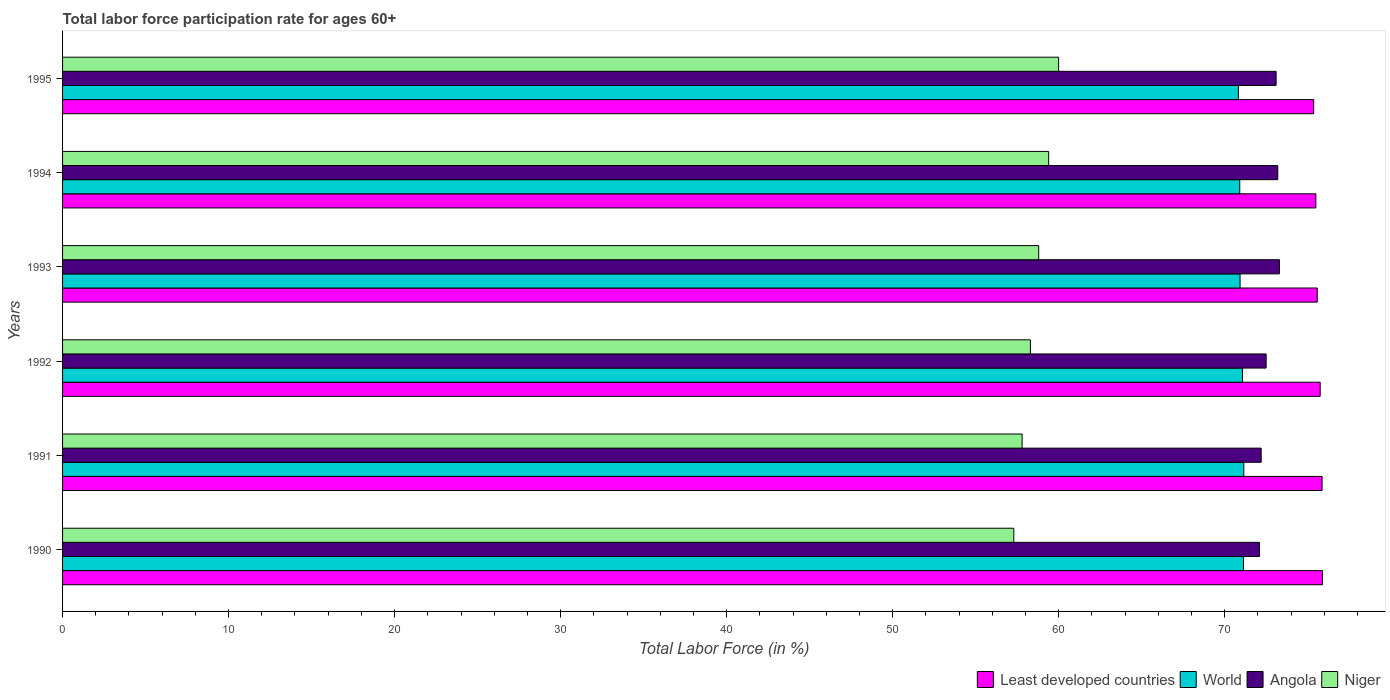How many different coloured bars are there?
Your answer should be compact. 4. How many groups of bars are there?
Ensure brevity in your answer.  6. Are the number of bars on each tick of the Y-axis equal?
Ensure brevity in your answer.  Yes. How many bars are there on the 3rd tick from the bottom?
Offer a terse response. 4. What is the label of the 2nd group of bars from the top?
Make the answer very short. 1994. In how many cases, is the number of bars for a given year not equal to the number of legend labels?
Provide a short and direct response. 0. What is the labor force participation rate in Niger in 1991?
Offer a terse response. 57.8. Across all years, what is the minimum labor force participation rate in Niger?
Provide a succinct answer. 57.3. In which year was the labor force participation rate in Angola maximum?
Provide a succinct answer. 1993. In which year was the labor force participation rate in Least developed countries minimum?
Provide a short and direct response. 1995. What is the total labor force participation rate in Angola in the graph?
Ensure brevity in your answer.  436.4. What is the difference between the labor force participation rate in Angola in 1990 and that in 1992?
Provide a short and direct response. -0.4. What is the difference between the labor force participation rate in World in 1992 and the labor force participation rate in Niger in 1991?
Your answer should be very brief. 13.28. What is the average labor force participation rate in Angola per year?
Keep it short and to the point. 72.73. In the year 1993, what is the difference between the labor force participation rate in Least developed countries and labor force participation rate in Niger?
Provide a short and direct response. 16.78. In how many years, is the labor force participation rate in Angola greater than 22 %?
Provide a short and direct response. 6. What is the ratio of the labor force participation rate in World in 1990 to that in 1991?
Ensure brevity in your answer.  1. Is the labor force participation rate in Niger in 1992 less than that in 1993?
Give a very brief answer. Yes. What is the difference between the highest and the second highest labor force participation rate in World?
Ensure brevity in your answer.  0.02. What is the difference between the highest and the lowest labor force participation rate in Niger?
Give a very brief answer. 2.7. In how many years, is the labor force participation rate in World greater than the average labor force participation rate in World taken over all years?
Your response must be concise. 3. What does the 4th bar from the top in 1992 represents?
Ensure brevity in your answer.  Least developed countries. What does the 3rd bar from the bottom in 1992 represents?
Make the answer very short. Angola. Is it the case that in every year, the sum of the labor force participation rate in Angola and labor force participation rate in Niger is greater than the labor force participation rate in World?
Offer a very short reply. Yes. How many bars are there?
Your answer should be compact. 24. Are all the bars in the graph horizontal?
Make the answer very short. Yes. How many years are there in the graph?
Keep it short and to the point. 6. What is the difference between two consecutive major ticks on the X-axis?
Provide a succinct answer. 10. Where does the legend appear in the graph?
Provide a succinct answer. Bottom right. What is the title of the graph?
Your answer should be very brief. Total labor force participation rate for ages 60+. Does "Puerto Rico" appear as one of the legend labels in the graph?
Your answer should be compact. No. What is the label or title of the X-axis?
Keep it short and to the point. Total Labor Force (in %). What is the Total Labor Force (in %) of Least developed countries in 1990?
Provide a succinct answer. 75.89. What is the Total Labor Force (in %) of World in 1990?
Your answer should be compact. 71.13. What is the Total Labor Force (in %) of Angola in 1990?
Provide a succinct answer. 72.1. What is the Total Labor Force (in %) in Niger in 1990?
Your response must be concise. 57.3. What is the Total Labor Force (in %) in Least developed countries in 1991?
Make the answer very short. 75.87. What is the Total Labor Force (in %) of World in 1991?
Provide a succinct answer. 71.15. What is the Total Labor Force (in %) of Angola in 1991?
Offer a terse response. 72.2. What is the Total Labor Force (in %) of Niger in 1991?
Provide a short and direct response. 57.8. What is the Total Labor Force (in %) in Least developed countries in 1992?
Your response must be concise. 75.75. What is the Total Labor Force (in %) of World in 1992?
Your answer should be compact. 71.08. What is the Total Labor Force (in %) of Angola in 1992?
Give a very brief answer. 72.5. What is the Total Labor Force (in %) of Niger in 1992?
Keep it short and to the point. 58.3. What is the Total Labor Force (in %) in Least developed countries in 1993?
Provide a succinct answer. 75.58. What is the Total Labor Force (in %) in World in 1993?
Your answer should be very brief. 70.93. What is the Total Labor Force (in %) of Angola in 1993?
Offer a terse response. 73.3. What is the Total Labor Force (in %) of Niger in 1993?
Make the answer very short. 58.8. What is the Total Labor Force (in %) of Least developed countries in 1994?
Your answer should be very brief. 75.49. What is the Total Labor Force (in %) in World in 1994?
Offer a terse response. 70.91. What is the Total Labor Force (in %) in Angola in 1994?
Offer a very short reply. 73.2. What is the Total Labor Force (in %) of Niger in 1994?
Your response must be concise. 59.4. What is the Total Labor Force (in %) in Least developed countries in 1995?
Your response must be concise. 75.36. What is the Total Labor Force (in %) in World in 1995?
Offer a terse response. 70.83. What is the Total Labor Force (in %) in Angola in 1995?
Offer a terse response. 73.1. What is the Total Labor Force (in %) in Niger in 1995?
Make the answer very short. 60. Across all years, what is the maximum Total Labor Force (in %) of Least developed countries?
Make the answer very short. 75.89. Across all years, what is the maximum Total Labor Force (in %) in World?
Make the answer very short. 71.15. Across all years, what is the maximum Total Labor Force (in %) of Angola?
Provide a succinct answer. 73.3. Across all years, what is the maximum Total Labor Force (in %) of Niger?
Offer a very short reply. 60. Across all years, what is the minimum Total Labor Force (in %) in Least developed countries?
Make the answer very short. 75.36. Across all years, what is the minimum Total Labor Force (in %) of World?
Offer a terse response. 70.83. Across all years, what is the minimum Total Labor Force (in %) in Angola?
Offer a very short reply. 72.1. Across all years, what is the minimum Total Labor Force (in %) of Niger?
Make the answer very short. 57.3. What is the total Total Labor Force (in %) of Least developed countries in the graph?
Offer a terse response. 453.95. What is the total Total Labor Force (in %) in World in the graph?
Ensure brevity in your answer.  426.03. What is the total Total Labor Force (in %) in Angola in the graph?
Make the answer very short. 436.4. What is the total Total Labor Force (in %) of Niger in the graph?
Ensure brevity in your answer.  351.6. What is the difference between the Total Labor Force (in %) in Least developed countries in 1990 and that in 1991?
Your answer should be compact. 0.03. What is the difference between the Total Labor Force (in %) in World in 1990 and that in 1991?
Make the answer very short. -0.02. What is the difference between the Total Labor Force (in %) in Niger in 1990 and that in 1991?
Offer a very short reply. -0.5. What is the difference between the Total Labor Force (in %) in Least developed countries in 1990 and that in 1992?
Make the answer very short. 0.14. What is the difference between the Total Labor Force (in %) of World in 1990 and that in 1992?
Make the answer very short. 0.06. What is the difference between the Total Labor Force (in %) in Angola in 1990 and that in 1992?
Provide a succinct answer. -0.4. What is the difference between the Total Labor Force (in %) in Least developed countries in 1990 and that in 1993?
Provide a short and direct response. 0.32. What is the difference between the Total Labor Force (in %) of World in 1990 and that in 1993?
Provide a short and direct response. 0.2. What is the difference between the Total Labor Force (in %) in Angola in 1990 and that in 1993?
Your response must be concise. -1.2. What is the difference between the Total Labor Force (in %) in World in 1990 and that in 1994?
Provide a succinct answer. 0.22. What is the difference between the Total Labor Force (in %) in Angola in 1990 and that in 1994?
Offer a very short reply. -1.1. What is the difference between the Total Labor Force (in %) of Least developed countries in 1990 and that in 1995?
Provide a short and direct response. 0.53. What is the difference between the Total Labor Force (in %) of World in 1990 and that in 1995?
Your answer should be very brief. 0.3. What is the difference between the Total Labor Force (in %) of Angola in 1990 and that in 1995?
Make the answer very short. -1. What is the difference between the Total Labor Force (in %) in Least developed countries in 1991 and that in 1992?
Offer a terse response. 0.11. What is the difference between the Total Labor Force (in %) of World in 1991 and that in 1992?
Your answer should be compact. 0.08. What is the difference between the Total Labor Force (in %) in Angola in 1991 and that in 1992?
Offer a very short reply. -0.3. What is the difference between the Total Labor Force (in %) of Least developed countries in 1991 and that in 1993?
Your answer should be very brief. 0.29. What is the difference between the Total Labor Force (in %) in World in 1991 and that in 1993?
Give a very brief answer. 0.22. What is the difference between the Total Labor Force (in %) of Angola in 1991 and that in 1993?
Provide a succinct answer. -1.1. What is the difference between the Total Labor Force (in %) in Least developed countries in 1991 and that in 1994?
Give a very brief answer. 0.37. What is the difference between the Total Labor Force (in %) of World in 1991 and that in 1994?
Your answer should be compact. 0.24. What is the difference between the Total Labor Force (in %) in Least developed countries in 1991 and that in 1995?
Keep it short and to the point. 0.51. What is the difference between the Total Labor Force (in %) in World in 1991 and that in 1995?
Give a very brief answer. 0.32. What is the difference between the Total Labor Force (in %) of Angola in 1991 and that in 1995?
Your answer should be compact. -0.9. What is the difference between the Total Labor Force (in %) in Niger in 1991 and that in 1995?
Offer a terse response. -2.2. What is the difference between the Total Labor Force (in %) of Least developed countries in 1992 and that in 1993?
Provide a short and direct response. 0.18. What is the difference between the Total Labor Force (in %) of World in 1992 and that in 1993?
Your response must be concise. 0.15. What is the difference between the Total Labor Force (in %) in Least developed countries in 1992 and that in 1994?
Offer a very short reply. 0.26. What is the difference between the Total Labor Force (in %) of World in 1992 and that in 1994?
Make the answer very short. 0.17. What is the difference between the Total Labor Force (in %) of Least developed countries in 1992 and that in 1995?
Provide a succinct answer. 0.39. What is the difference between the Total Labor Force (in %) in World in 1992 and that in 1995?
Provide a short and direct response. 0.25. What is the difference between the Total Labor Force (in %) in Least developed countries in 1993 and that in 1994?
Offer a terse response. 0.08. What is the difference between the Total Labor Force (in %) of World in 1993 and that in 1994?
Make the answer very short. 0.02. What is the difference between the Total Labor Force (in %) of Angola in 1993 and that in 1994?
Offer a terse response. 0.1. What is the difference between the Total Labor Force (in %) in Least developed countries in 1993 and that in 1995?
Provide a short and direct response. 0.22. What is the difference between the Total Labor Force (in %) in Niger in 1993 and that in 1995?
Give a very brief answer. -1.2. What is the difference between the Total Labor Force (in %) of Least developed countries in 1994 and that in 1995?
Your answer should be compact. 0.13. What is the difference between the Total Labor Force (in %) in World in 1994 and that in 1995?
Provide a succinct answer. 0.08. What is the difference between the Total Labor Force (in %) of Niger in 1994 and that in 1995?
Your answer should be very brief. -0.6. What is the difference between the Total Labor Force (in %) of Least developed countries in 1990 and the Total Labor Force (in %) of World in 1991?
Keep it short and to the point. 4.74. What is the difference between the Total Labor Force (in %) in Least developed countries in 1990 and the Total Labor Force (in %) in Angola in 1991?
Give a very brief answer. 3.69. What is the difference between the Total Labor Force (in %) in Least developed countries in 1990 and the Total Labor Force (in %) in Niger in 1991?
Ensure brevity in your answer.  18.09. What is the difference between the Total Labor Force (in %) of World in 1990 and the Total Labor Force (in %) of Angola in 1991?
Offer a terse response. -1.07. What is the difference between the Total Labor Force (in %) of World in 1990 and the Total Labor Force (in %) of Niger in 1991?
Your answer should be very brief. 13.33. What is the difference between the Total Labor Force (in %) in Least developed countries in 1990 and the Total Labor Force (in %) in World in 1992?
Offer a very short reply. 4.82. What is the difference between the Total Labor Force (in %) of Least developed countries in 1990 and the Total Labor Force (in %) of Angola in 1992?
Offer a terse response. 3.39. What is the difference between the Total Labor Force (in %) of Least developed countries in 1990 and the Total Labor Force (in %) of Niger in 1992?
Ensure brevity in your answer.  17.59. What is the difference between the Total Labor Force (in %) of World in 1990 and the Total Labor Force (in %) of Angola in 1992?
Give a very brief answer. -1.37. What is the difference between the Total Labor Force (in %) in World in 1990 and the Total Labor Force (in %) in Niger in 1992?
Your response must be concise. 12.83. What is the difference between the Total Labor Force (in %) in Angola in 1990 and the Total Labor Force (in %) in Niger in 1992?
Your answer should be compact. 13.8. What is the difference between the Total Labor Force (in %) of Least developed countries in 1990 and the Total Labor Force (in %) of World in 1993?
Your answer should be compact. 4.97. What is the difference between the Total Labor Force (in %) in Least developed countries in 1990 and the Total Labor Force (in %) in Angola in 1993?
Ensure brevity in your answer.  2.59. What is the difference between the Total Labor Force (in %) in Least developed countries in 1990 and the Total Labor Force (in %) in Niger in 1993?
Your answer should be compact. 17.09. What is the difference between the Total Labor Force (in %) in World in 1990 and the Total Labor Force (in %) in Angola in 1993?
Give a very brief answer. -2.17. What is the difference between the Total Labor Force (in %) in World in 1990 and the Total Labor Force (in %) in Niger in 1993?
Ensure brevity in your answer.  12.33. What is the difference between the Total Labor Force (in %) in Least developed countries in 1990 and the Total Labor Force (in %) in World in 1994?
Offer a terse response. 4.98. What is the difference between the Total Labor Force (in %) of Least developed countries in 1990 and the Total Labor Force (in %) of Angola in 1994?
Your response must be concise. 2.69. What is the difference between the Total Labor Force (in %) in Least developed countries in 1990 and the Total Labor Force (in %) in Niger in 1994?
Make the answer very short. 16.49. What is the difference between the Total Labor Force (in %) of World in 1990 and the Total Labor Force (in %) of Angola in 1994?
Your answer should be very brief. -2.07. What is the difference between the Total Labor Force (in %) of World in 1990 and the Total Labor Force (in %) of Niger in 1994?
Provide a succinct answer. 11.73. What is the difference between the Total Labor Force (in %) in Least developed countries in 1990 and the Total Labor Force (in %) in World in 1995?
Your answer should be compact. 5.07. What is the difference between the Total Labor Force (in %) of Least developed countries in 1990 and the Total Labor Force (in %) of Angola in 1995?
Give a very brief answer. 2.79. What is the difference between the Total Labor Force (in %) in Least developed countries in 1990 and the Total Labor Force (in %) in Niger in 1995?
Give a very brief answer. 15.89. What is the difference between the Total Labor Force (in %) of World in 1990 and the Total Labor Force (in %) of Angola in 1995?
Provide a succinct answer. -1.97. What is the difference between the Total Labor Force (in %) of World in 1990 and the Total Labor Force (in %) of Niger in 1995?
Provide a short and direct response. 11.13. What is the difference between the Total Labor Force (in %) of Least developed countries in 1991 and the Total Labor Force (in %) of World in 1992?
Keep it short and to the point. 4.79. What is the difference between the Total Labor Force (in %) in Least developed countries in 1991 and the Total Labor Force (in %) in Angola in 1992?
Offer a very short reply. 3.37. What is the difference between the Total Labor Force (in %) of Least developed countries in 1991 and the Total Labor Force (in %) of Niger in 1992?
Give a very brief answer. 17.57. What is the difference between the Total Labor Force (in %) of World in 1991 and the Total Labor Force (in %) of Angola in 1992?
Give a very brief answer. -1.35. What is the difference between the Total Labor Force (in %) in World in 1991 and the Total Labor Force (in %) in Niger in 1992?
Offer a terse response. 12.85. What is the difference between the Total Labor Force (in %) of Angola in 1991 and the Total Labor Force (in %) of Niger in 1992?
Offer a terse response. 13.9. What is the difference between the Total Labor Force (in %) in Least developed countries in 1991 and the Total Labor Force (in %) in World in 1993?
Offer a terse response. 4.94. What is the difference between the Total Labor Force (in %) in Least developed countries in 1991 and the Total Labor Force (in %) in Angola in 1993?
Your answer should be compact. 2.57. What is the difference between the Total Labor Force (in %) of Least developed countries in 1991 and the Total Labor Force (in %) of Niger in 1993?
Offer a very short reply. 17.07. What is the difference between the Total Labor Force (in %) of World in 1991 and the Total Labor Force (in %) of Angola in 1993?
Make the answer very short. -2.15. What is the difference between the Total Labor Force (in %) of World in 1991 and the Total Labor Force (in %) of Niger in 1993?
Ensure brevity in your answer.  12.35. What is the difference between the Total Labor Force (in %) in Least developed countries in 1991 and the Total Labor Force (in %) in World in 1994?
Provide a short and direct response. 4.96. What is the difference between the Total Labor Force (in %) in Least developed countries in 1991 and the Total Labor Force (in %) in Angola in 1994?
Offer a very short reply. 2.67. What is the difference between the Total Labor Force (in %) of Least developed countries in 1991 and the Total Labor Force (in %) of Niger in 1994?
Offer a terse response. 16.47. What is the difference between the Total Labor Force (in %) of World in 1991 and the Total Labor Force (in %) of Angola in 1994?
Provide a short and direct response. -2.05. What is the difference between the Total Labor Force (in %) of World in 1991 and the Total Labor Force (in %) of Niger in 1994?
Ensure brevity in your answer.  11.75. What is the difference between the Total Labor Force (in %) in Angola in 1991 and the Total Labor Force (in %) in Niger in 1994?
Provide a short and direct response. 12.8. What is the difference between the Total Labor Force (in %) in Least developed countries in 1991 and the Total Labor Force (in %) in World in 1995?
Provide a short and direct response. 5.04. What is the difference between the Total Labor Force (in %) of Least developed countries in 1991 and the Total Labor Force (in %) of Angola in 1995?
Provide a succinct answer. 2.77. What is the difference between the Total Labor Force (in %) of Least developed countries in 1991 and the Total Labor Force (in %) of Niger in 1995?
Provide a succinct answer. 15.87. What is the difference between the Total Labor Force (in %) in World in 1991 and the Total Labor Force (in %) in Angola in 1995?
Your answer should be compact. -1.95. What is the difference between the Total Labor Force (in %) of World in 1991 and the Total Labor Force (in %) of Niger in 1995?
Offer a very short reply. 11.15. What is the difference between the Total Labor Force (in %) in Angola in 1991 and the Total Labor Force (in %) in Niger in 1995?
Offer a terse response. 12.2. What is the difference between the Total Labor Force (in %) in Least developed countries in 1992 and the Total Labor Force (in %) in World in 1993?
Ensure brevity in your answer.  4.83. What is the difference between the Total Labor Force (in %) in Least developed countries in 1992 and the Total Labor Force (in %) in Angola in 1993?
Offer a very short reply. 2.45. What is the difference between the Total Labor Force (in %) of Least developed countries in 1992 and the Total Labor Force (in %) of Niger in 1993?
Offer a very short reply. 16.95. What is the difference between the Total Labor Force (in %) of World in 1992 and the Total Labor Force (in %) of Angola in 1993?
Give a very brief answer. -2.22. What is the difference between the Total Labor Force (in %) of World in 1992 and the Total Labor Force (in %) of Niger in 1993?
Make the answer very short. 12.28. What is the difference between the Total Labor Force (in %) in Least developed countries in 1992 and the Total Labor Force (in %) in World in 1994?
Your answer should be very brief. 4.84. What is the difference between the Total Labor Force (in %) of Least developed countries in 1992 and the Total Labor Force (in %) of Angola in 1994?
Offer a terse response. 2.55. What is the difference between the Total Labor Force (in %) in Least developed countries in 1992 and the Total Labor Force (in %) in Niger in 1994?
Your answer should be compact. 16.35. What is the difference between the Total Labor Force (in %) of World in 1992 and the Total Labor Force (in %) of Angola in 1994?
Ensure brevity in your answer.  -2.12. What is the difference between the Total Labor Force (in %) in World in 1992 and the Total Labor Force (in %) in Niger in 1994?
Your answer should be very brief. 11.68. What is the difference between the Total Labor Force (in %) of Angola in 1992 and the Total Labor Force (in %) of Niger in 1994?
Provide a short and direct response. 13.1. What is the difference between the Total Labor Force (in %) of Least developed countries in 1992 and the Total Labor Force (in %) of World in 1995?
Give a very brief answer. 4.93. What is the difference between the Total Labor Force (in %) of Least developed countries in 1992 and the Total Labor Force (in %) of Angola in 1995?
Keep it short and to the point. 2.65. What is the difference between the Total Labor Force (in %) of Least developed countries in 1992 and the Total Labor Force (in %) of Niger in 1995?
Offer a terse response. 15.75. What is the difference between the Total Labor Force (in %) in World in 1992 and the Total Labor Force (in %) in Angola in 1995?
Offer a very short reply. -2.02. What is the difference between the Total Labor Force (in %) in World in 1992 and the Total Labor Force (in %) in Niger in 1995?
Give a very brief answer. 11.08. What is the difference between the Total Labor Force (in %) in Angola in 1992 and the Total Labor Force (in %) in Niger in 1995?
Ensure brevity in your answer.  12.5. What is the difference between the Total Labor Force (in %) in Least developed countries in 1993 and the Total Labor Force (in %) in World in 1994?
Your answer should be very brief. 4.67. What is the difference between the Total Labor Force (in %) in Least developed countries in 1993 and the Total Labor Force (in %) in Angola in 1994?
Your answer should be very brief. 2.38. What is the difference between the Total Labor Force (in %) of Least developed countries in 1993 and the Total Labor Force (in %) of Niger in 1994?
Provide a succinct answer. 16.18. What is the difference between the Total Labor Force (in %) of World in 1993 and the Total Labor Force (in %) of Angola in 1994?
Provide a short and direct response. -2.27. What is the difference between the Total Labor Force (in %) in World in 1993 and the Total Labor Force (in %) in Niger in 1994?
Provide a succinct answer. 11.53. What is the difference between the Total Labor Force (in %) of Angola in 1993 and the Total Labor Force (in %) of Niger in 1994?
Your response must be concise. 13.9. What is the difference between the Total Labor Force (in %) of Least developed countries in 1993 and the Total Labor Force (in %) of World in 1995?
Your answer should be very brief. 4.75. What is the difference between the Total Labor Force (in %) of Least developed countries in 1993 and the Total Labor Force (in %) of Angola in 1995?
Your response must be concise. 2.48. What is the difference between the Total Labor Force (in %) in Least developed countries in 1993 and the Total Labor Force (in %) in Niger in 1995?
Provide a succinct answer. 15.58. What is the difference between the Total Labor Force (in %) of World in 1993 and the Total Labor Force (in %) of Angola in 1995?
Keep it short and to the point. -2.17. What is the difference between the Total Labor Force (in %) in World in 1993 and the Total Labor Force (in %) in Niger in 1995?
Provide a succinct answer. 10.93. What is the difference between the Total Labor Force (in %) of Angola in 1993 and the Total Labor Force (in %) of Niger in 1995?
Offer a terse response. 13.3. What is the difference between the Total Labor Force (in %) in Least developed countries in 1994 and the Total Labor Force (in %) in World in 1995?
Your answer should be compact. 4.67. What is the difference between the Total Labor Force (in %) of Least developed countries in 1994 and the Total Labor Force (in %) of Angola in 1995?
Keep it short and to the point. 2.39. What is the difference between the Total Labor Force (in %) in Least developed countries in 1994 and the Total Labor Force (in %) in Niger in 1995?
Offer a terse response. 15.49. What is the difference between the Total Labor Force (in %) in World in 1994 and the Total Labor Force (in %) in Angola in 1995?
Make the answer very short. -2.19. What is the difference between the Total Labor Force (in %) in World in 1994 and the Total Labor Force (in %) in Niger in 1995?
Your response must be concise. 10.91. What is the difference between the Total Labor Force (in %) in Angola in 1994 and the Total Labor Force (in %) in Niger in 1995?
Ensure brevity in your answer.  13.2. What is the average Total Labor Force (in %) of Least developed countries per year?
Ensure brevity in your answer.  75.66. What is the average Total Labor Force (in %) of World per year?
Keep it short and to the point. 71.01. What is the average Total Labor Force (in %) of Angola per year?
Provide a short and direct response. 72.73. What is the average Total Labor Force (in %) in Niger per year?
Keep it short and to the point. 58.6. In the year 1990, what is the difference between the Total Labor Force (in %) in Least developed countries and Total Labor Force (in %) in World?
Provide a succinct answer. 4.76. In the year 1990, what is the difference between the Total Labor Force (in %) in Least developed countries and Total Labor Force (in %) in Angola?
Your answer should be compact. 3.79. In the year 1990, what is the difference between the Total Labor Force (in %) in Least developed countries and Total Labor Force (in %) in Niger?
Your answer should be very brief. 18.59. In the year 1990, what is the difference between the Total Labor Force (in %) in World and Total Labor Force (in %) in Angola?
Give a very brief answer. -0.97. In the year 1990, what is the difference between the Total Labor Force (in %) of World and Total Labor Force (in %) of Niger?
Offer a terse response. 13.83. In the year 1990, what is the difference between the Total Labor Force (in %) of Angola and Total Labor Force (in %) of Niger?
Ensure brevity in your answer.  14.8. In the year 1991, what is the difference between the Total Labor Force (in %) of Least developed countries and Total Labor Force (in %) of World?
Ensure brevity in your answer.  4.72. In the year 1991, what is the difference between the Total Labor Force (in %) of Least developed countries and Total Labor Force (in %) of Angola?
Your answer should be very brief. 3.67. In the year 1991, what is the difference between the Total Labor Force (in %) in Least developed countries and Total Labor Force (in %) in Niger?
Provide a succinct answer. 18.07. In the year 1991, what is the difference between the Total Labor Force (in %) in World and Total Labor Force (in %) in Angola?
Offer a terse response. -1.05. In the year 1991, what is the difference between the Total Labor Force (in %) in World and Total Labor Force (in %) in Niger?
Keep it short and to the point. 13.35. In the year 1992, what is the difference between the Total Labor Force (in %) in Least developed countries and Total Labor Force (in %) in World?
Your response must be concise. 4.68. In the year 1992, what is the difference between the Total Labor Force (in %) in Least developed countries and Total Labor Force (in %) in Angola?
Make the answer very short. 3.25. In the year 1992, what is the difference between the Total Labor Force (in %) in Least developed countries and Total Labor Force (in %) in Niger?
Make the answer very short. 17.45. In the year 1992, what is the difference between the Total Labor Force (in %) in World and Total Labor Force (in %) in Angola?
Your answer should be compact. -1.42. In the year 1992, what is the difference between the Total Labor Force (in %) in World and Total Labor Force (in %) in Niger?
Your response must be concise. 12.78. In the year 1993, what is the difference between the Total Labor Force (in %) of Least developed countries and Total Labor Force (in %) of World?
Your response must be concise. 4.65. In the year 1993, what is the difference between the Total Labor Force (in %) in Least developed countries and Total Labor Force (in %) in Angola?
Provide a short and direct response. 2.28. In the year 1993, what is the difference between the Total Labor Force (in %) in Least developed countries and Total Labor Force (in %) in Niger?
Your answer should be compact. 16.78. In the year 1993, what is the difference between the Total Labor Force (in %) of World and Total Labor Force (in %) of Angola?
Give a very brief answer. -2.37. In the year 1993, what is the difference between the Total Labor Force (in %) in World and Total Labor Force (in %) in Niger?
Make the answer very short. 12.13. In the year 1993, what is the difference between the Total Labor Force (in %) of Angola and Total Labor Force (in %) of Niger?
Your answer should be compact. 14.5. In the year 1994, what is the difference between the Total Labor Force (in %) of Least developed countries and Total Labor Force (in %) of World?
Provide a succinct answer. 4.58. In the year 1994, what is the difference between the Total Labor Force (in %) of Least developed countries and Total Labor Force (in %) of Angola?
Offer a terse response. 2.29. In the year 1994, what is the difference between the Total Labor Force (in %) in Least developed countries and Total Labor Force (in %) in Niger?
Offer a very short reply. 16.09. In the year 1994, what is the difference between the Total Labor Force (in %) in World and Total Labor Force (in %) in Angola?
Your response must be concise. -2.29. In the year 1994, what is the difference between the Total Labor Force (in %) in World and Total Labor Force (in %) in Niger?
Give a very brief answer. 11.51. In the year 1994, what is the difference between the Total Labor Force (in %) of Angola and Total Labor Force (in %) of Niger?
Your response must be concise. 13.8. In the year 1995, what is the difference between the Total Labor Force (in %) in Least developed countries and Total Labor Force (in %) in World?
Make the answer very short. 4.53. In the year 1995, what is the difference between the Total Labor Force (in %) in Least developed countries and Total Labor Force (in %) in Angola?
Provide a short and direct response. 2.26. In the year 1995, what is the difference between the Total Labor Force (in %) in Least developed countries and Total Labor Force (in %) in Niger?
Offer a terse response. 15.36. In the year 1995, what is the difference between the Total Labor Force (in %) of World and Total Labor Force (in %) of Angola?
Give a very brief answer. -2.27. In the year 1995, what is the difference between the Total Labor Force (in %) in World and Total Labor Force (in %) in Niger?
Offer a terse response. 10.83. What is the ratio of the Total Labor Force (in %) of Niger in 1990 to that in 1991?
Provide a short and direct response. 0.99. What is the ratio of the Total Labor Force (in %) in Least developed countries in 1990 to that in 1992?
Give a very brief answer. 1. What is the ratio of the Total Labor Force (in %) of World in 1990 to that in 1992?
Offer a terse response. 1. What is the ratio of the Total Labor Force (in %) of Angola in 1990 to that in 1992?
Give a very brief answer. 0.99. What is the ratio of the Total Labor Force (in %) of Niger in 1990 to that in 1992?
Your answer should be compact. 0.98. What is the ratio of the Total Labor Force (in %) in Angola in 1990 to that in 1993?
Make the answer very short. 0.98. What is the ratio of the Total Labor Force (in %) in Niger in 1990 to that in 1993?
Keep it short and to the point. 0.97. What is the ratio of the Total Labor Force (in %) in World in 1990 to that in 1994?
Offer a terse response. 1. What is the ratio of the Total Labor Force (in %) of Niger in 1990 to that in 1994?
Your response must be concise. 0.96. What is the ratio of the Total Labor Force (in %) in Least developed countries in 1990 to that in 1995?
Offer a terse response. 1.01. What is the ratio of the Total Labor Force (in %) in World in 1990 to that in 1995?
Make the answer very short. 1. What is the ratio of the Total Labor Force (in %) of Angola in 1990 to that in 1995?
Keep it short and to the point. 0.99. What is the ratio of the Total Labor Force (in %) of Niger in 1990 to that in 1995?
Your answer should be compact. 0.95. What is the ratio of the Total Labor Force (in %) in Least developed countries in 1991 to that in 1992?
Your answer should be compact. 1. What is the ratio of the Total Labor Force (in %) in World in 1991 to that in 1992?
Your answer should be very brief. 1. What is the ratio of the Total Labor Force (in %) of Least developed countries in 1991 to that in 1993?
Give a very brief answer. 1. What is the ratio of the Total Labor Force (in %) of World in 1991 to that in 1993?
Your response must be concise. 1. What is the ratio of the Total Labor Force (in %) in Niger in 1991 to that in 1993?
Offer a terse response. 0.98. What is the ratio of the Total Labor Force (in %) of Angola in 1991 to that in 1994?
Provide a short and direct response. 0.99. What is the ratio of the Total Labor Force (in %) in Niger in 1991 to that in 1994?
Provide a short and direct response. 0.97. What is the ratio of the Total Labor Force (in %) of Niger in 1991 to that in 1995?
Make the answer very short. 0.96. What is the ratio of the Total Labor Force (in %) of Least developed countries in 1992 to that in 1993?
Provide a short and direct response. 1. What is the ratio of the Total Labor Force (in %) in World in 1992 to that in 1993?
Your answer should be compact. 1. What is the ratio of the Total Labor Force (in %) of Niger in 1992 to that in 1994?
Provide a short and direct response. 0.98. What is the ratio of the Total Labor Force (in %) of Least developed countries in 1992 to that in 1995?
Your answer should be very brief. 1.01. What is the ratio of the Total Labor Force (in %) of Niger in 1992 to that in 1995?
Offer a very short reply. 0.97. What is the ratio of the Total Labor Force (in %) of Least developed countries in 1993 to that in 1994?
Provide a short and direct response. 1. What is the ratio of the Total Labor Force (in %) in World in 1993 to that in 1994?
Offer a very short reply. 1. What is the ratio of the Total Labor Force (in %) in Niger in 1993 to that in 1994?
Your response must be concise. 0.99. What is the ratio of the Total Labor Force (in %) in Least developed countries in 1993 to that in 1995?
Provide a short and direct response. 1. What is the ratio of the Total Labor Force (in %) of Niger in 1994 to that in 1995?
Make the answer very short. 0.99. What is the difference between the highest and the second highest Total Labor Force (in %) of Least developed countries?
Keep it short and to the point. 0.03. What is the difference between the highest and the second highest Total Labor Force (in %) of World?
Provide a succinct answer. 0.02. What is the difference between the highest and the second highest Total Labor Force (in %) of Angola?
Ensure brevity in your answer.  0.1. What is the difference between the highest and the second highest Total Labor Force (in %) of Niger?
Make the answer very short. 0.6. What is the difference between the highest and the lowest Total Labor Force (in %) in Least developed countries?
Your response must be concise. 0.53. What is the difference between the highest and the lowest Total Labor Force (in %) of World?
Offer a very short reply. 0.32. What is the difference between the highest and the lowest Total Labor Force (in %) of Angola?
Provide a short and direct response. 1.2. What is the difference between the highest and the lowest Total Labor Force (in %) in Niger?
Your answer should be compact. 2.7. 